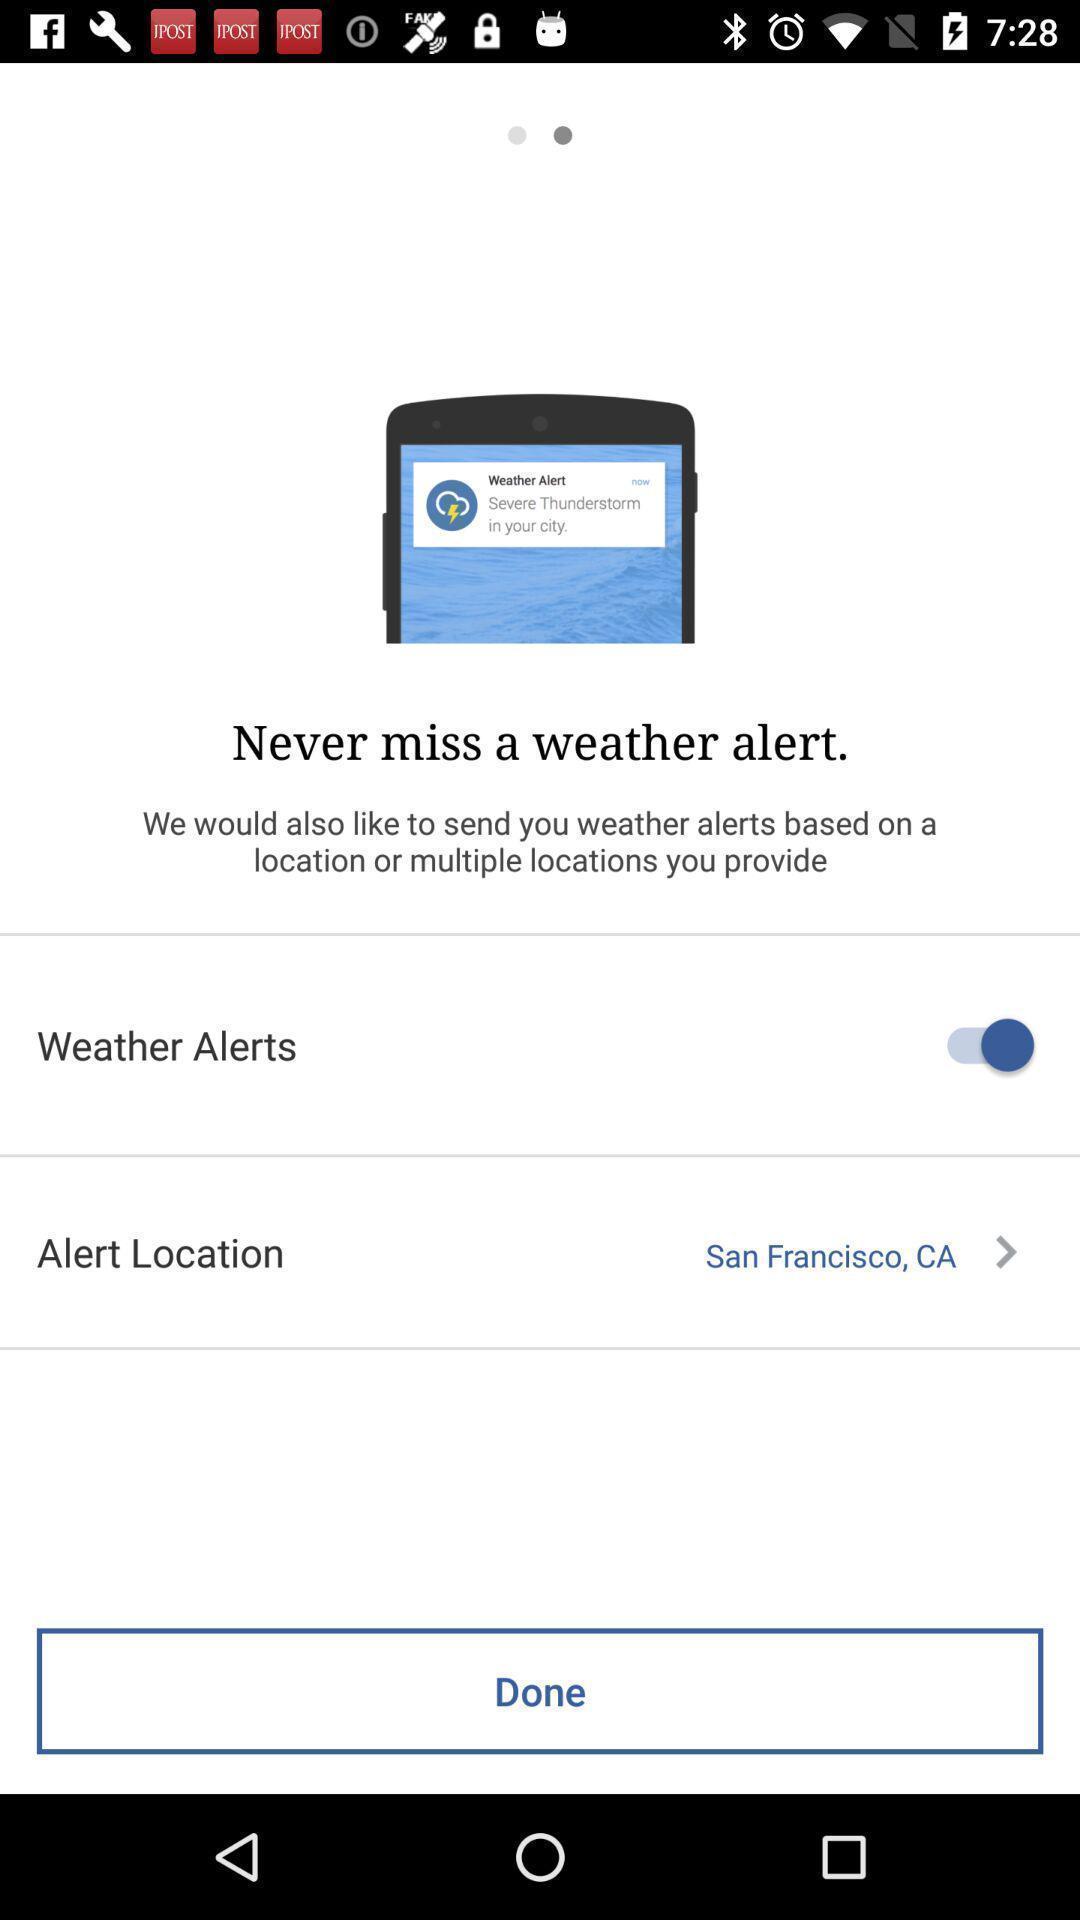What is the overall content of this screenshot? Welcome page of a weather alerts application. 